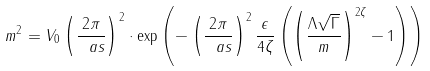Convert formula to latex. <formula><loc_0><loc_0><loc_500><loc_500>m ^ { 2 } = V _ { 0 } \left ( \frac { 2 \pi } { \ a s } \right ) ^ { 2 } \cdot \exp \left ( { - \left ( \frac { 2 \pi } { \ a s } \right ) ^ { 2 } \frac { \epsilon } { 4 \zeta } \left ( \left ( \frac { \Lambda \sqrt { \Gamma } } m \right ) ^ { 2 \zeta } - 1 \right ) } \right )</formula> 